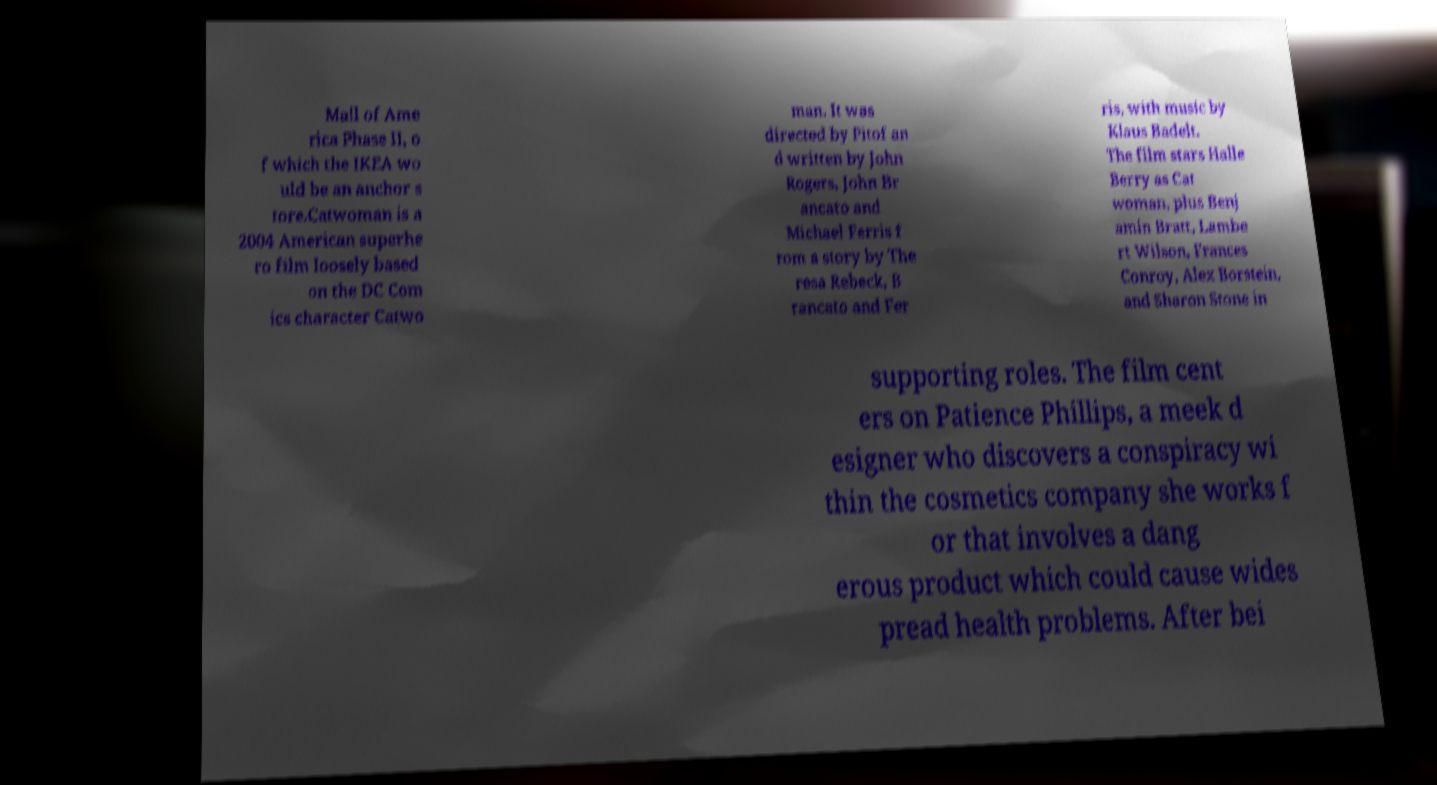For documentation purposes, I need the text within this image transcribed. Could you provide that? Mall of Ame rica Phase II, o f which the IKEA wo uld be an anchor s tore.Catwoman is a 2004 American superhe ro film loosely based on the DC Com ics character Catwo man. It was directed by Pitof an d written by John Rogers, John Br ancato and Michael Ferris f rom a story by The resa Rebeck, B rancato and Fer ris, with music by Klaus Badelt. The film stars Halle Berry as Cat woman, plus Benj amin Bratt, Lambe rt Wilson, Frances Conroy, Alex Borstein, and Sharon Stone in supporting roles. The film cent ers on Patience Phillips, a meek d esigner who discovers a conspiracy wi thin the cosmetics company she works f or that involves a dang erous product which could cause wides pread health problems. After bei 